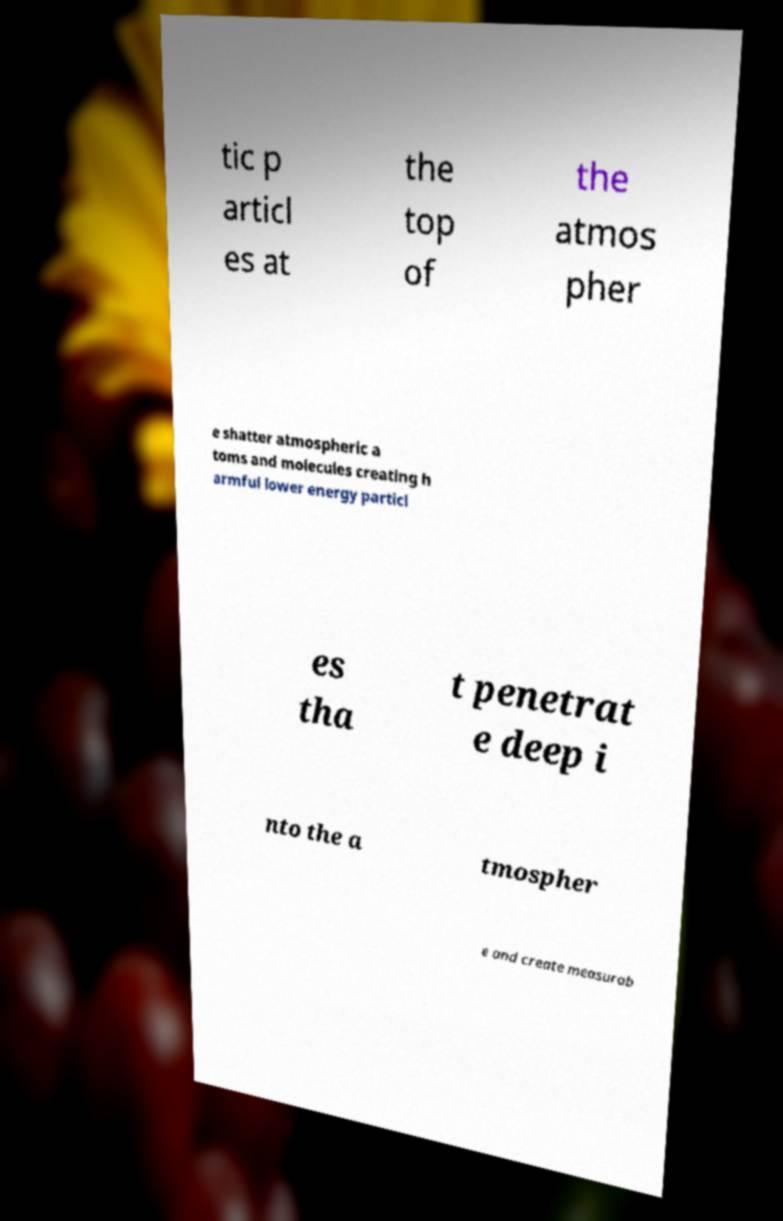Can you accurately transcribe the text from the provided image for me? tic p articl es at the top of the atmos pher e shatter atmospheric a toms and molecules creating h armful lower energy particl es tha t penetrat e deep i nto the a tmospher e and create measurab 